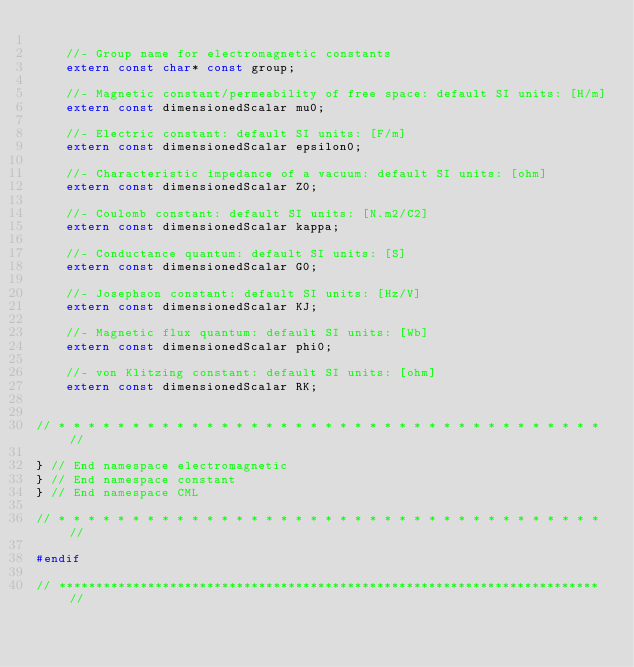Convert code to text. <code><loc_0><loc_0><loc_500><loc_500><_C++_>
    //- Group name for electromagnetic constants
    extern const char* const group;

    //- Magnetic constant/permeability of free space: default SI units: [H/m]
    extern const dimensionedScalar mu0;

    //- Electric constant: default SI units: [F/m]
    extern const dimensionedScalar epsilon0;

    //- Characteristic impedance of a vacuum: default SI units: [ohm]
    extern const dimensionedScalar Z0;

    //- Coulomb constant: default SI units: [N.m2/C2]
    extern const dimensionedScalar kappa;

    //- Conductance quantum: default SI units: [S]
    extern const dimensionedScalar G0;

    //- Josephson constant: default SI units: [Hz/V]
    extern const dimensionedScalar KJ;

    //- Magnetic flux quantum: default SI units: [Wb]
    extern const dimensionedScalar phi0;

    //- von Klitzing constant: default SI units: [ohm]
    extern const dimensionedScalar RK;


// * * * * * * * * * * * * * * * * * * * * * * * * * * * * * * * * * * * * * //

} // End namespace electromagnetic
} // End namespace constant
} // End namespace CML

// * * * * * * * * * * * * * * * * * * * * * * * * * * * * * * * * * * * * * //

#endif

// ************************************************************************* //
</code> 